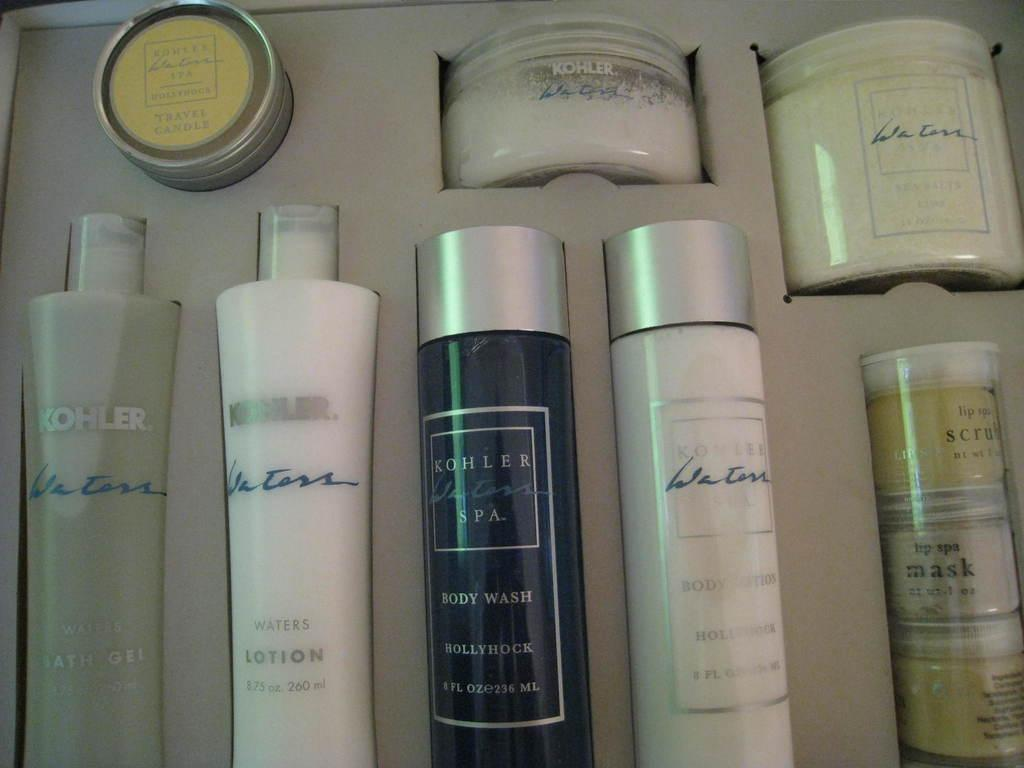What type of objects can be seen in the image? There are bottles and boxes in the image. How are the bottles and boxes arranged? The bottles and boxes are arranged in a box. Is there any text visible on the bottles and boxes? Yes, there is text visible on the bottles and boxes. How many corks can be seen in the image? There is no mention of corks in the image, so it is not possible to determine how many corks are present. 